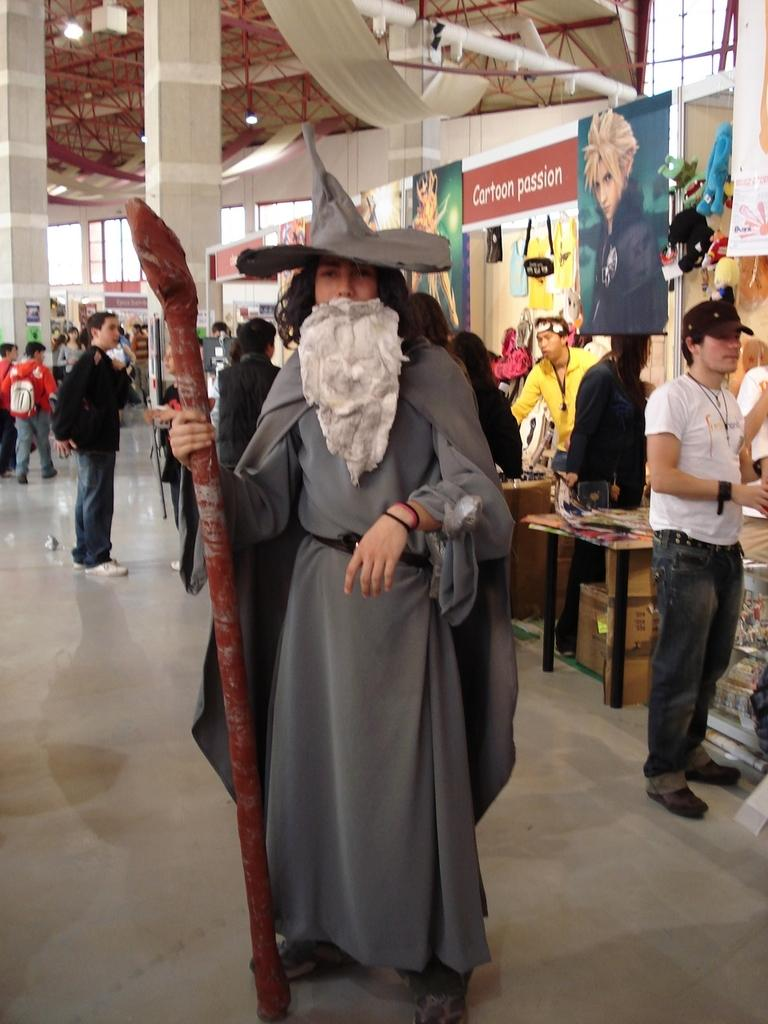What is the person holding in the image? There is a person standing holding an object, but the specific object is not mentioned in the facts. Can you describe the position of the second person in the image? There is another person standing towards the right in the image. What architectural feature can be seen in the image? There is a pillar in the image. What can be used for illumination in the image? There is a light in the image. What activity are some people engaged in within the image? There are people walking in the image. What type of horn can be heard in the image? There is no mention of a horn or any sound in the image. Where is the library located in the image? There is no mention of a library in the image. What type of clothing does the judge wear in the image? There is no mention of a judge or any person wearing specific clothing in the image. 